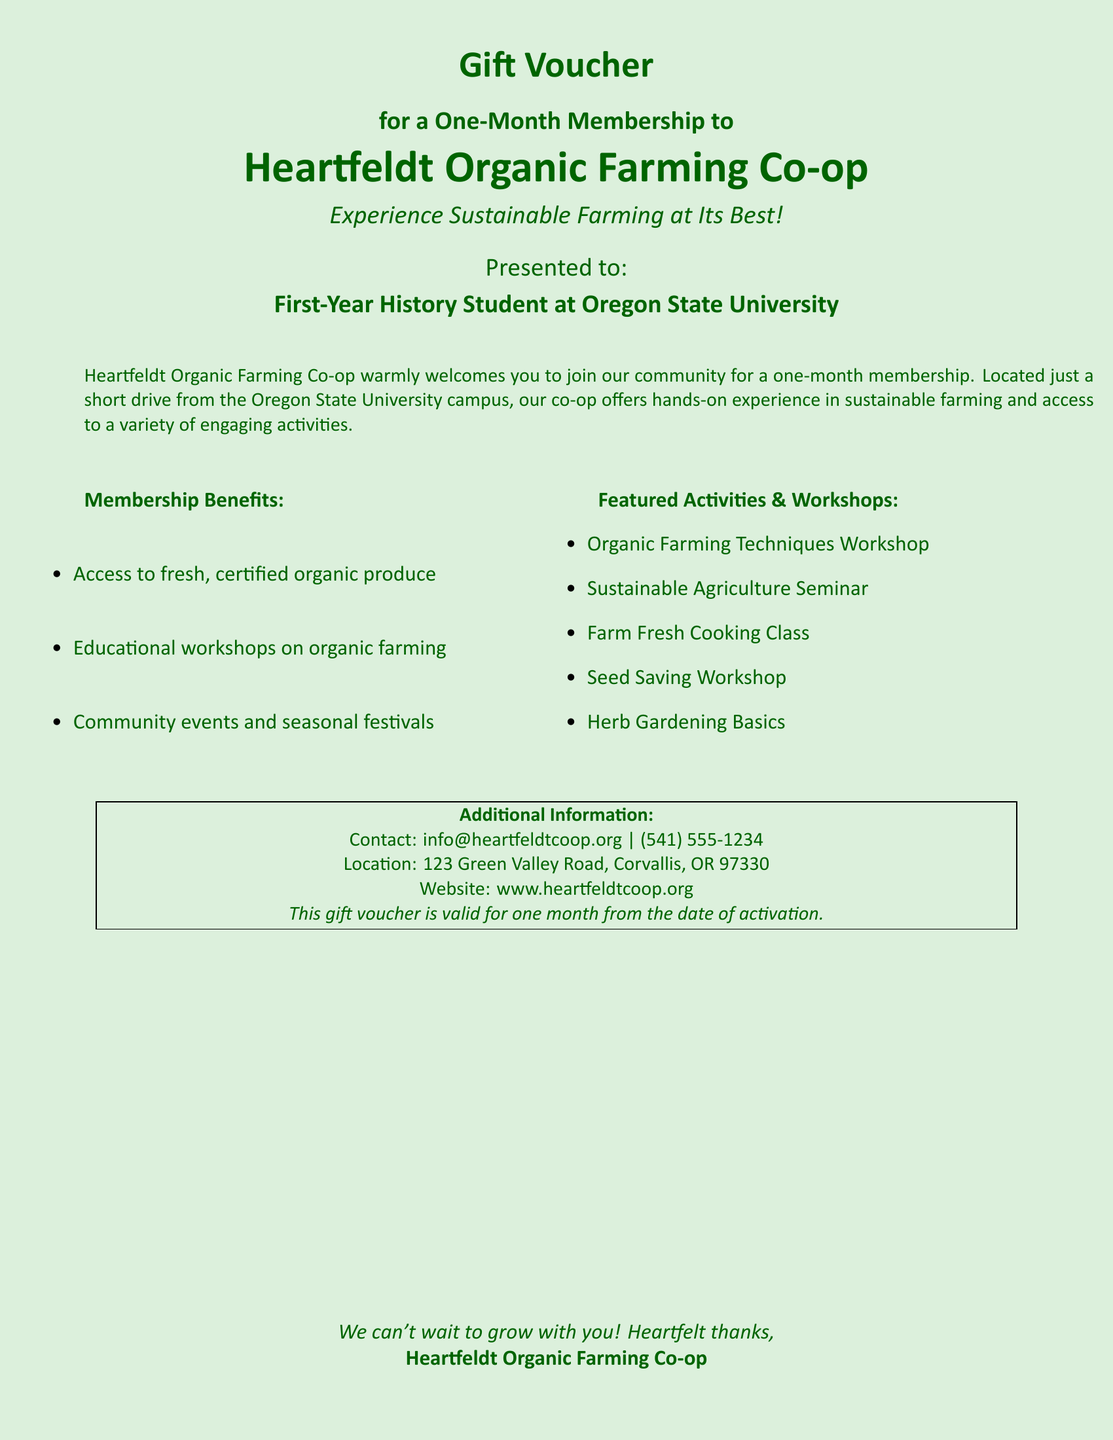What is the name of the co-op? The name of the co-op is mentioned in the title of the document.
Answer: Heartfeldt Organic Farming Co-op What type of produce will members have access to? The document states the produce type in the benefits section.
Answer: Fresh, certified organic produce What is one workshop offered to members? The document lists several workshops in the activities section.
Answer: Organic Farming Techniques Workshop Where is the co-op located? The location is specified in the additional information section.
Answer: 123 Green Valley Road, Corvallis, OR 97330 What is the contact email for the co-op? The contact email is provided in the additional information section of the document.
Answer: info@heartfeldtcoop.org How long is the gift voucher valid for? The validity period is mentioned in the additional information section.
Answer: One month What type of events are included in the membership benefits? The document outlines the events in the benefits section.
Answer: Community events and seasonal festivals What is the main theme of workshops at the co-op? The theme can be inferred from the listed workshops and their focus.
Answer: Sustainable farming 